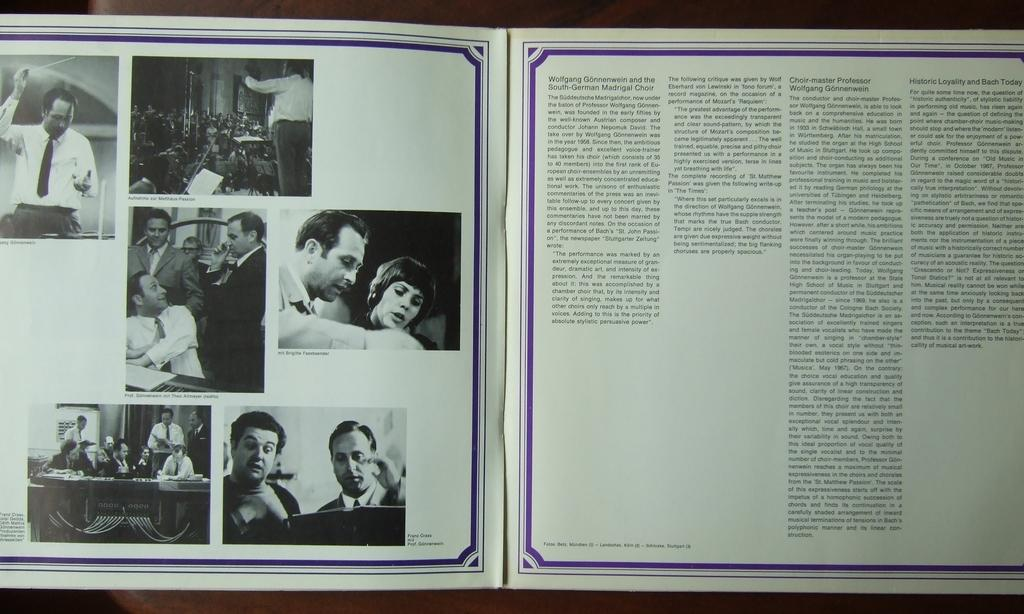<image>
Summarize the visual content of the image. An album insert for the South-German Madrigal Choir. 